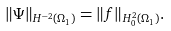<formula> <loc_0><loc_0><loc_500><loc_500>\| \Psi \| _ { H ^ { - 2 } ( \Omega _ { 1 } ) } = \| f \| _ { H _ { 0 } ^ { 2 } ( \Omega _ { 1 } ) } .</formula> 